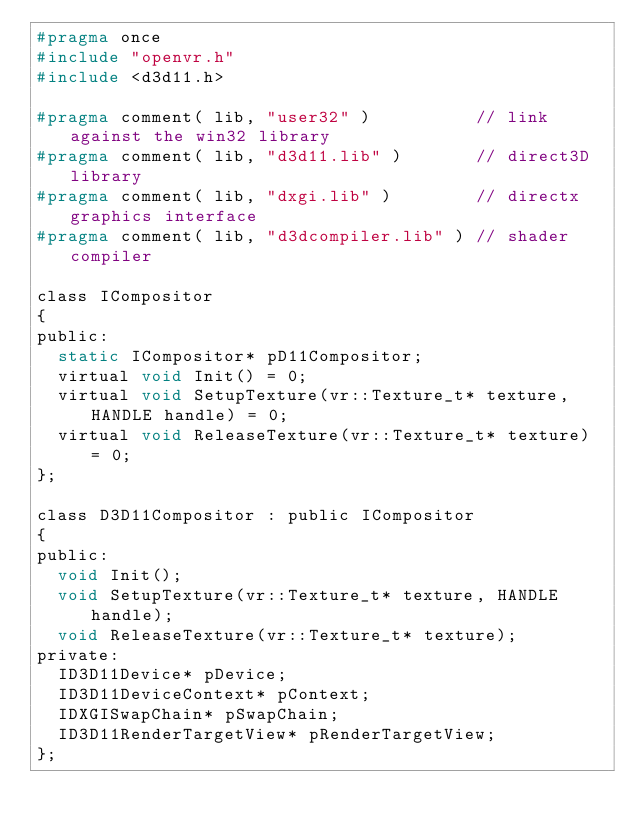<code> <loc_0><loc_0><loc_500><loc_500><_C_>#pragma once
#include "openvr.h"
#include <d3d11.h>

#pragma comment( lib, "user32" )          // link against the win32 library
#pragma comment( lib, "d3d11.lib" )       // direct3D library
#pragma comment( lib, "dxgi.lib" )        // directx graphics interface
#pragma comment( lib, "d3dcompiler.lib" ) // shader compiler

class ICompositor
{
public:
	static ICompositor* pD11Compositor;
	virtual void Init() = 0;
	virtual void SetupTexture(vr::Texture_t* texture, HANDLE handle) = 0;
	virtual void ReleaseTexture(vr::Texture_t* texture) = 0;
};

class D3D11Compositor : public ICompositor
{
public:
	void Init();
	void SetupTexture(vr::Texture_t* texture, HANDLE handle);
	void ReleaseTexture(vr::Texture_t* texture);
private:
	ID3D11Device* pDevice;
	ID3D11DeviceContext* pContext;
	IDXGISwapChain* pSwapChain;
	ID3D11RenderTargetView* pRenderTargetView;
};
</code> 